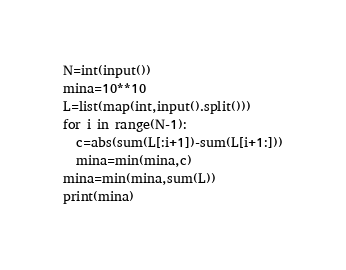<code> <loc_0><loc_0><loc_500><loc_500><_Python_>N=int(input())
mina=10**10
L=list(map(int,input().split()))
for i in range(N-1):
  c=abs(sum(L[:i+1])-sum(L[i+1:]))
  mina=min(mina,c)
mina=min(mina,sum(L))
print(mina)</code> 